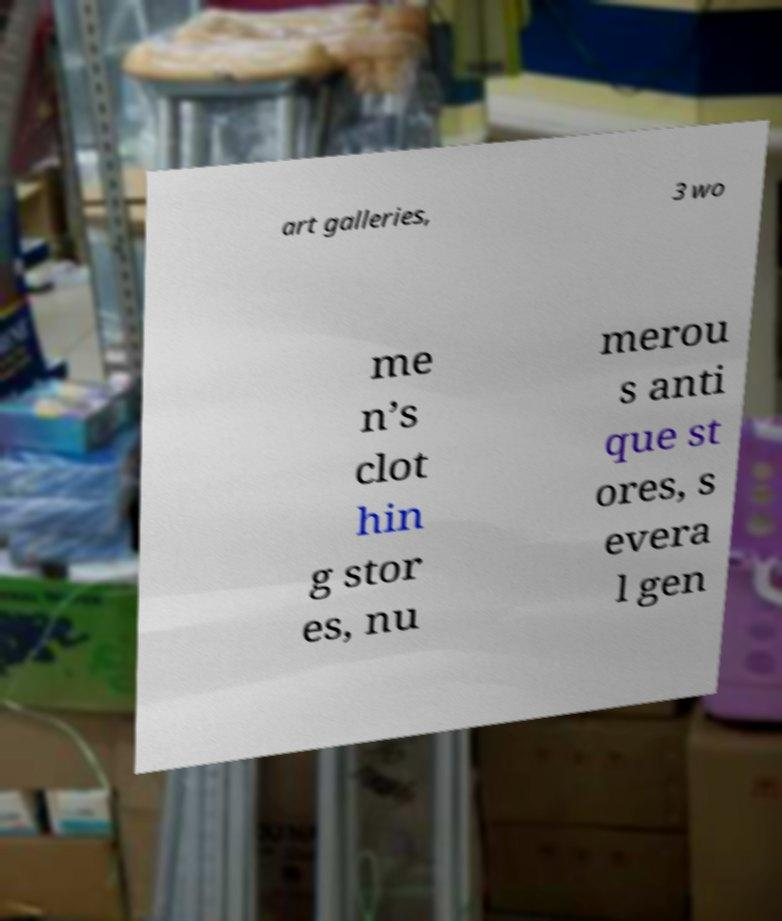I need the written content from this picture converted into text. Can you do that? art galleries, 3 wo me n’s clot hin g stor es, nu merou s anti que st ores, s evera l gen 